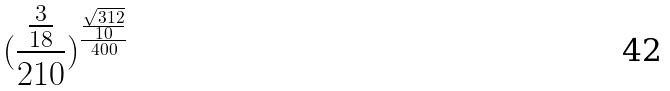<formula> <loc_0><loc_0><loc_500><loc_500>( \frac { \frac { 3 } { 1 8 } } { 2 1 0 } ) ^ { \frac { \frac { \sqrt { 3 1 2 } } { 1 0 } } { 4 0 0 } }</formula> 